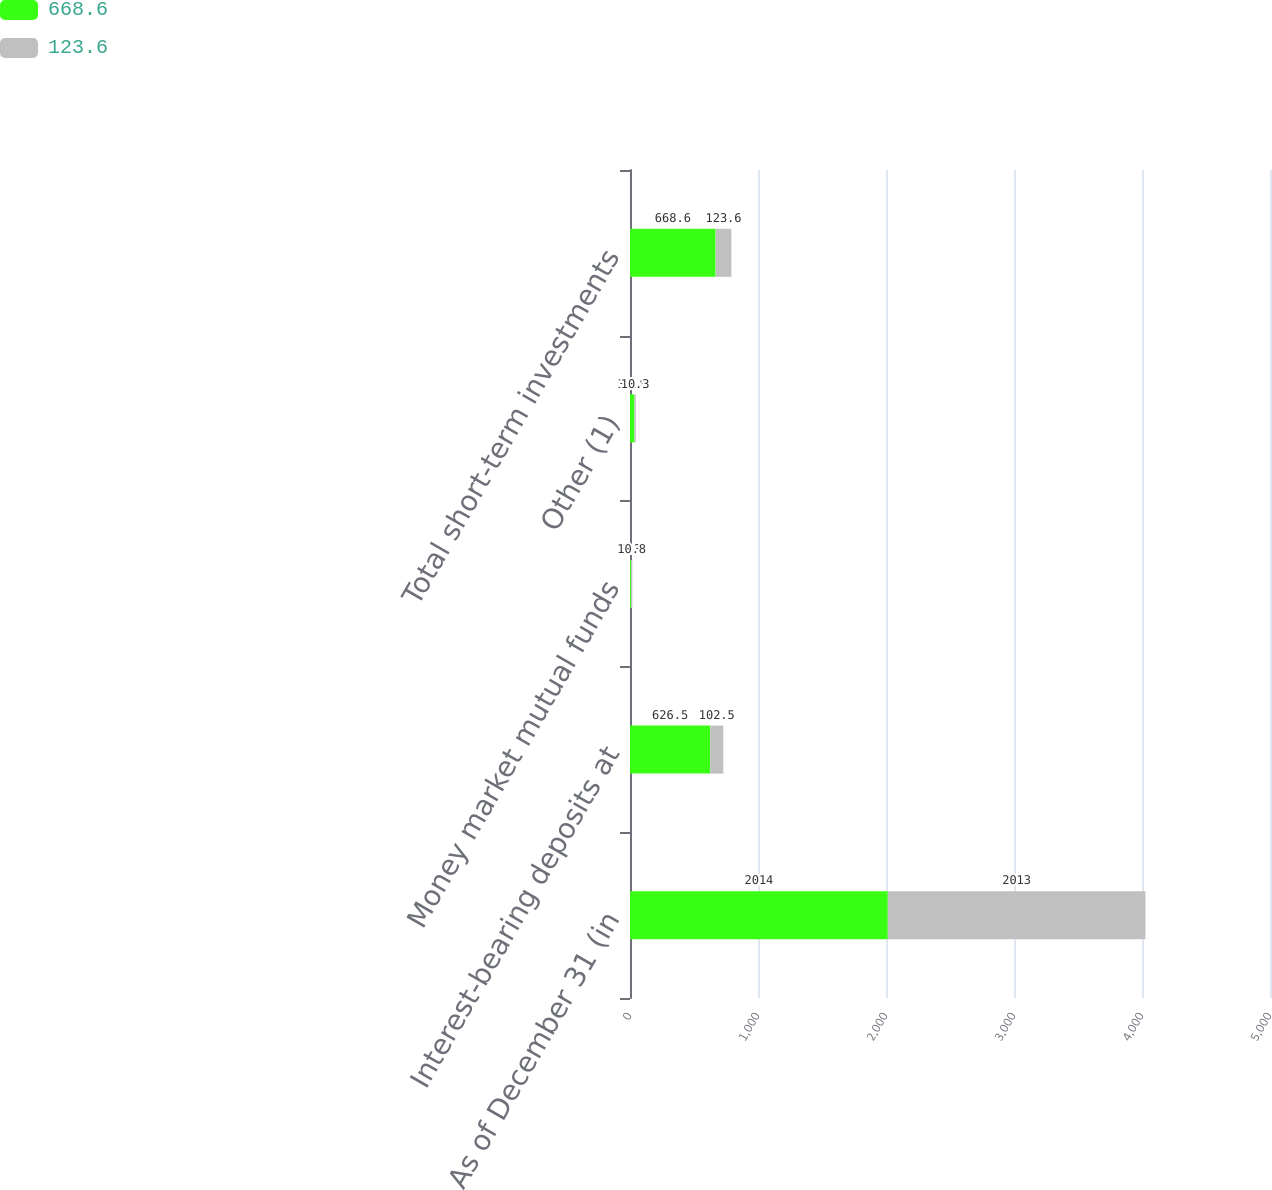<chart> <loc_0><loc_0><loc_500><loc_500><stacked_bar_chart><ecel><fcel>As of December 31 (in<fcel>Interest-bearing deposits at<fcel>Money market mutual funds<fcel>Other (1)<fcel>Total short-term investments<nl><fcel>668.6<fcel>2014<fcel>626.5<fcel>7.3<fcel>34.8<fcel>668.6<nl><fcel>123.6<fcel>2013<fcel>102.5<fcel>10.8<fcel>10.3<fcel>123.6<nl></chart> 